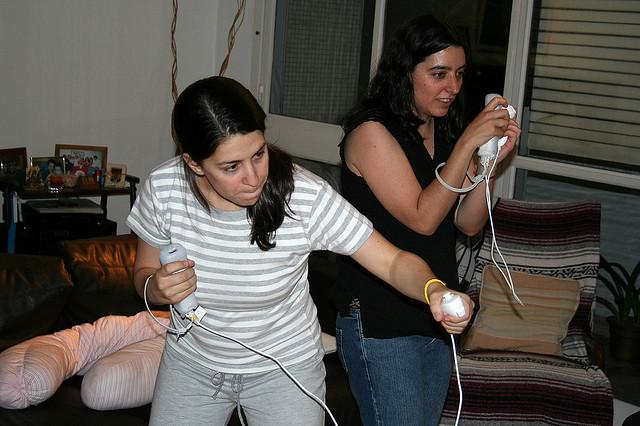What is probably in front of them? television 